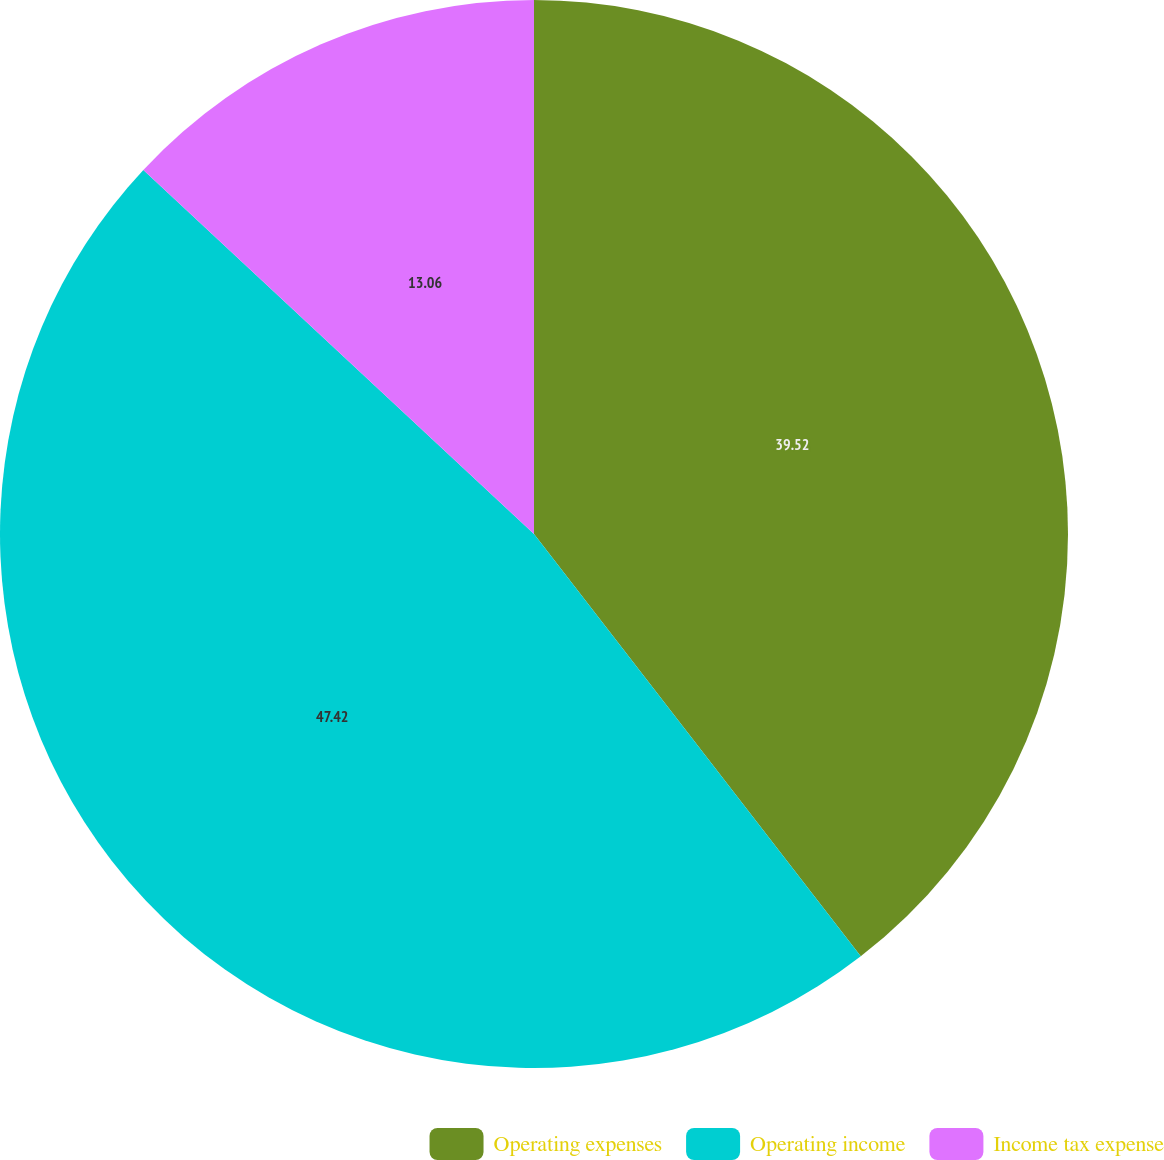Convert chart. <chart><loc_0><loc_0><loc_500><loc_500><pie_chart><fcel>Operating expenses<fcel>Operating income<fcel>Income tax expense<nl><fcel>39.52%<fcel>47.42%<fcel>13.06%<nl></chart> 